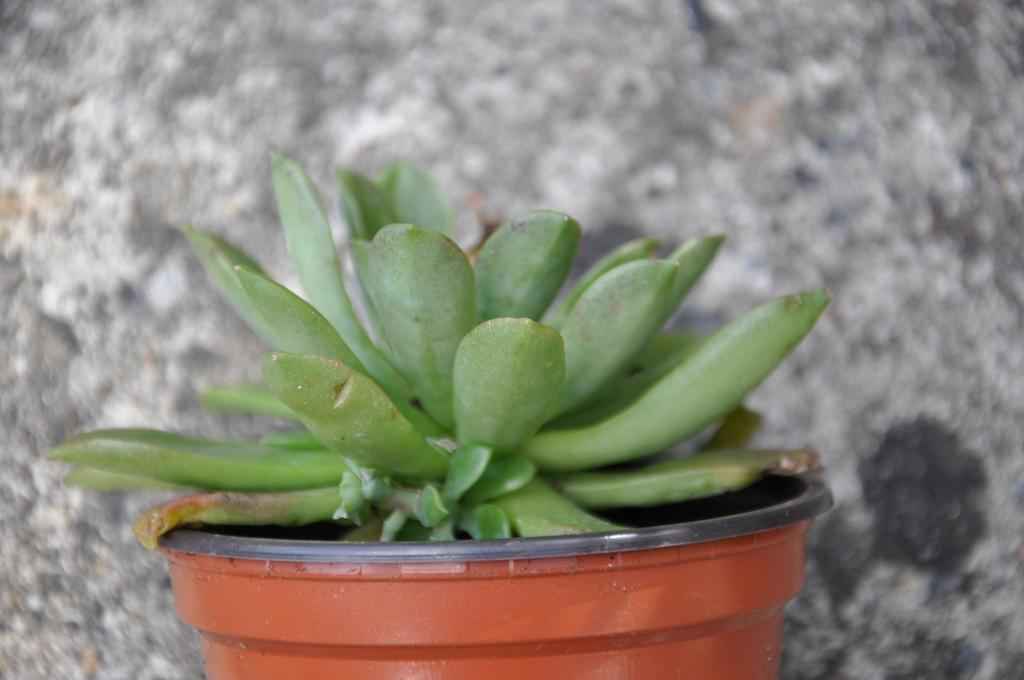What is the main subject in the center of the image? There is a plant in a pot in the center of the image. What can be seen in the background of the image? There is a wall in the background of the image. How many layers of cake can be seen in the image? There is no cake present in the image. What type of bird is perched on the plant in the image? There is no bird present in the image, let alone a robin. 